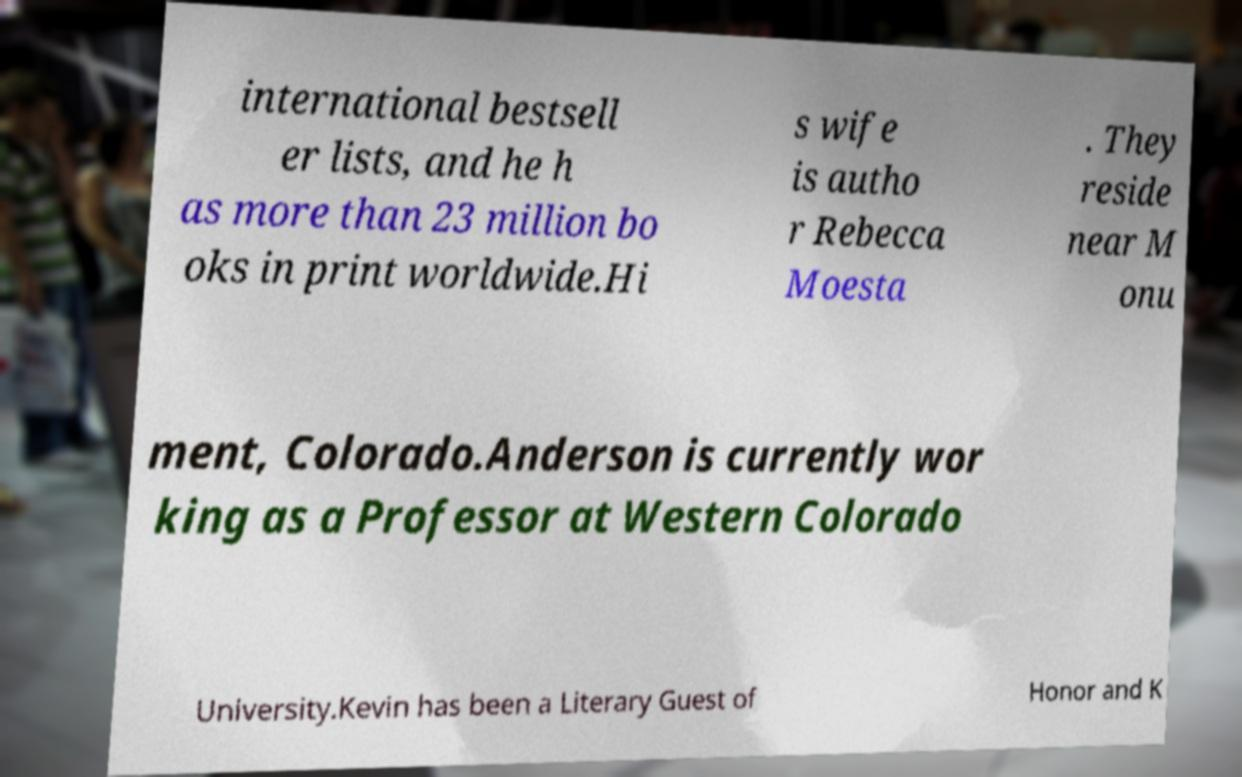Please identify and transcribe the text found in this image. international bestsell er lists, and he h as more than 23 million bo oks in print worldwide.Hi s wife is autho r Rebecca Moesta . They reside near M onu ment, Colorado.Anderson is currently wor king as a Professor at Western Colorado University.Kevin has been a Literary Guest of Honor and K 